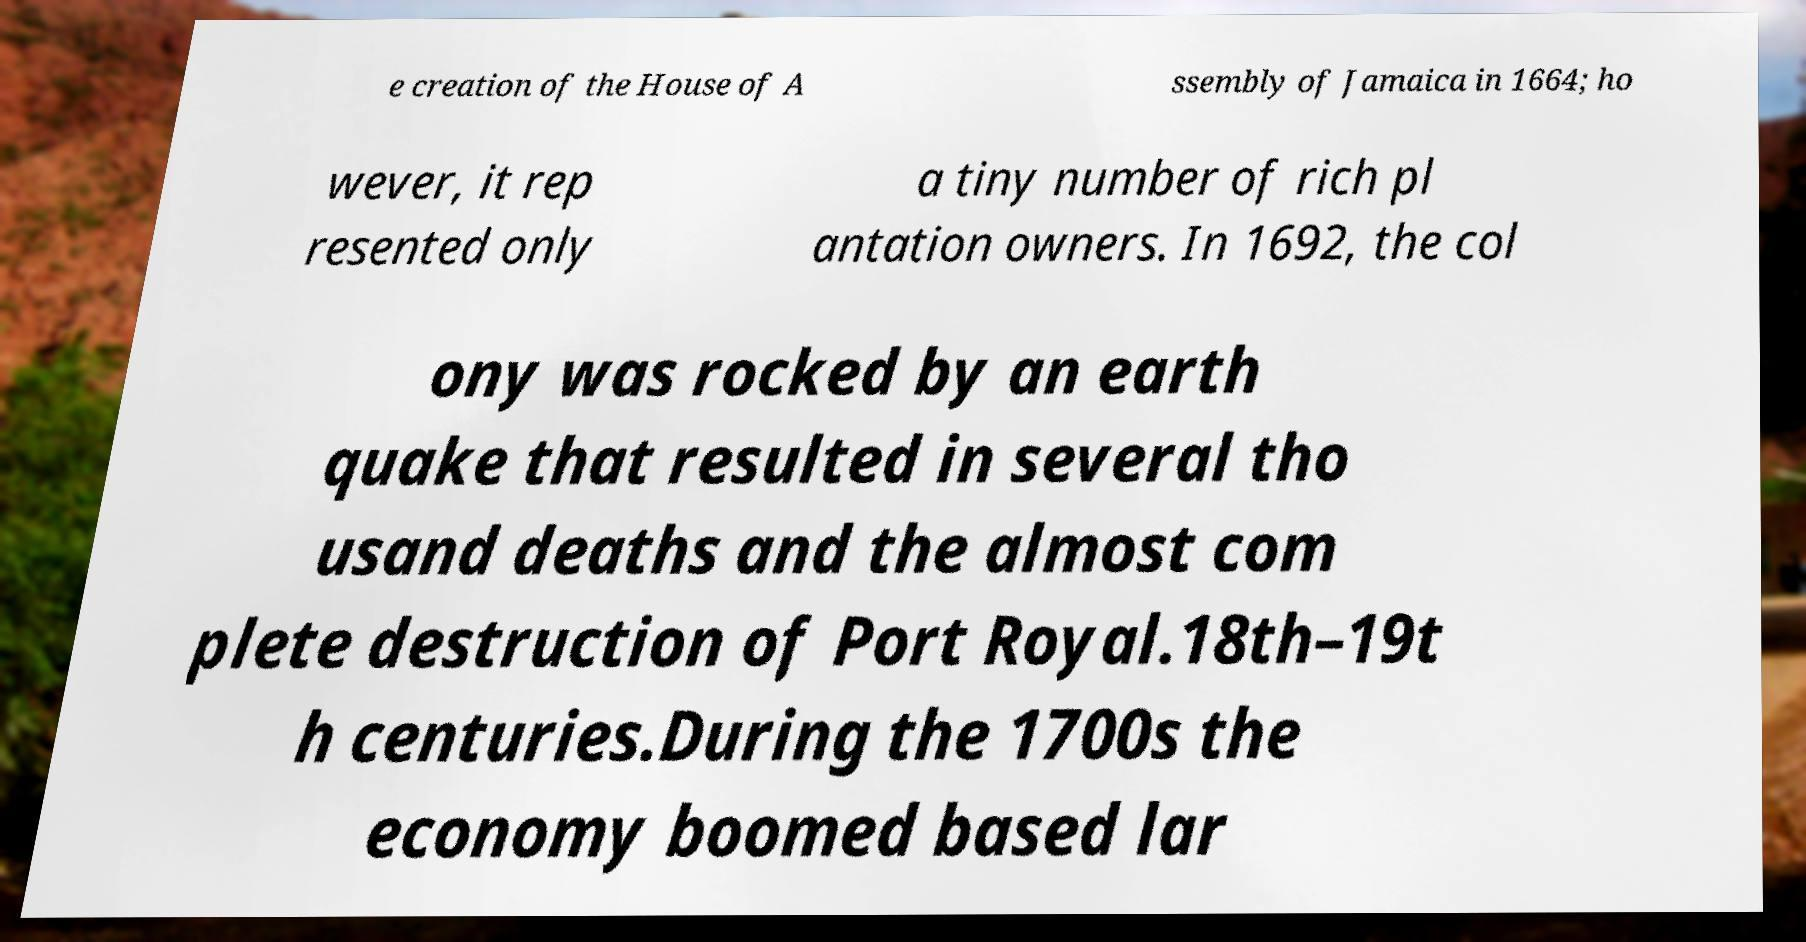Could you extract and type out the text from this image? e creation of the House of A ssembly of Jamaica in 1664; ho wever, it rep resented only a tiny number of rich pl antation owners. In 1692, the col ony was rocked by an earth quake that resulted in several tho usand deaths and the almost com plete destruction of Port Royal.18th–19t h centuries.During the 1700s the economy boomed based lar 